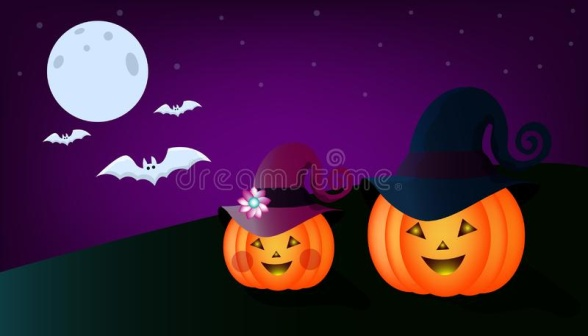Describe the emotions conveyed by this Halloween scene. The image evokes a blend of cheerfulness and spookiness. The smiling jack-o-lanterns with their festive hats suggest joy and playfulness, while the full moon and bats introduce an eerie, mysterious Halloween ambiance. Together, these elements create a fun and slightly spooky Halloween mood, perfect for celebrating the festive season. What story might these jack-o-lanterns be part of in a Halloween narrative? In a whimsical Halloween tale, these jack-o-lanterns could be magical guardians of a mystical hill. By day, they appear as ordinary pumpkins, but on Halloween night, they come to life. The jack-o-lantern on the left, with its purple hat adorned with a flower, could be the gentle and wise guardian, while the one on the right, donning a black witch's hat, might be the mischievous trickster. Together, they watch over the hill and ensure that only the bravest and kindest trick-or-treaters are rewarded with magical candies. As bats flutter under the watchful eye of the moon, the jack-o-lanterns share stories of old Halloweens and enchant the night with their glowing grins. If these jack-o-lanterns could speak, what do you think they would say to each other? The jack-o-lanterns might engage in spirited conversations about their Halloween adventures. The one with the purple hat might say, 'Look at the lovely glow of the moon tonight! It’s perfect for our annual Halloween gathering.' The other, with the witch's hat, might respond, 'Indeed! I hope we have lots of trick-or-treaters. I can’t wait to see their costumes and share spooky stories!' Together, they would laugh and reminisce about past Halloweens, eagerly awaiting the night’s festivities. 